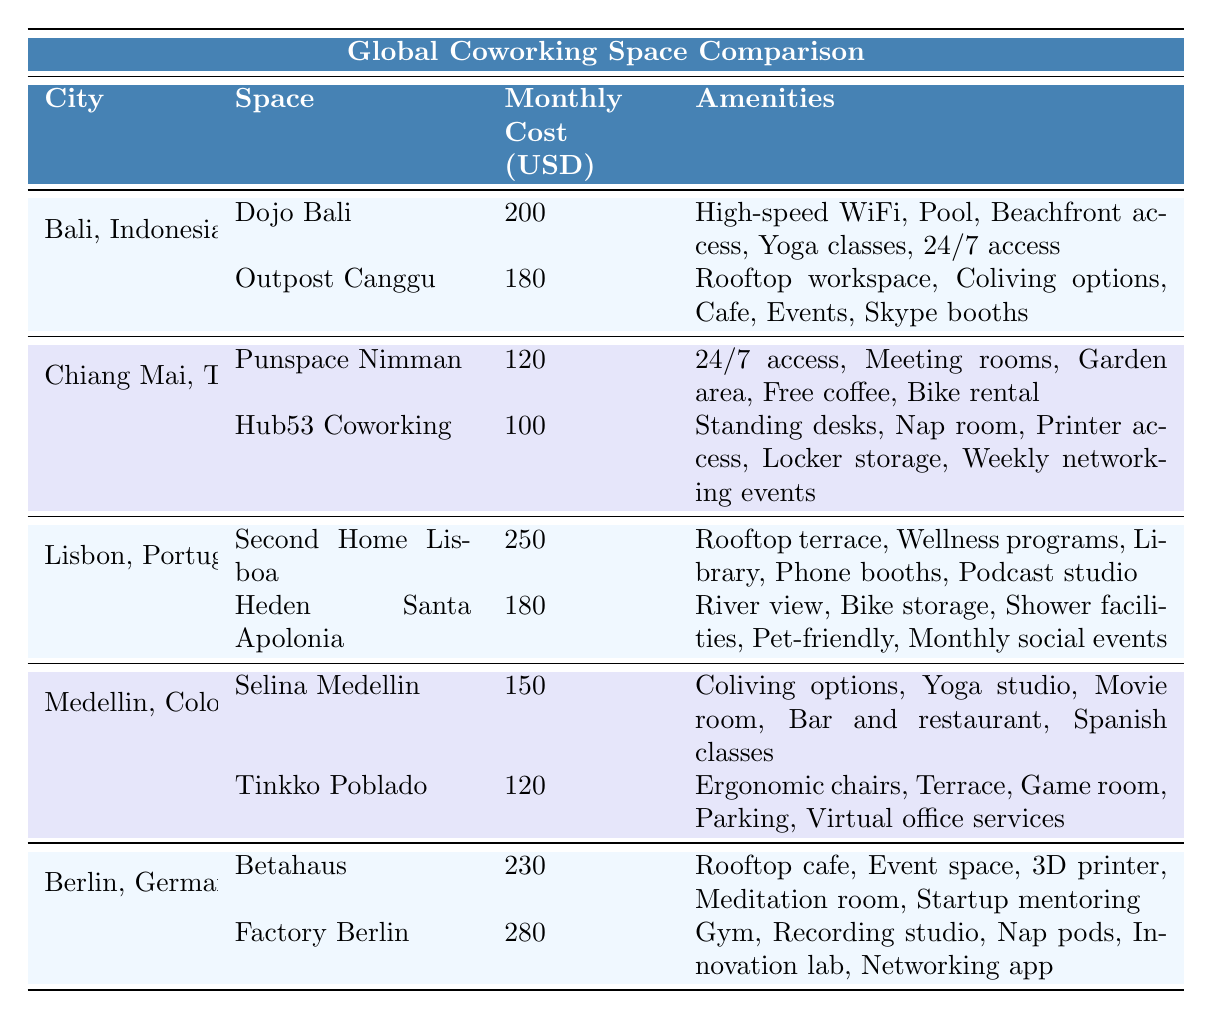What is the monthly cost of Dojo Bali? In the table, under the row for Bali, Indonesia, the monthly cost listed for Dojo Bali is directly provided as 200.
Answer: 200 How many amenities does Hub53 Coworking offer? For Hub53 Coworking in Chiang Mai, Thailand, there are five amenities listed: Standing desks, Nap room, Printer access, Locker storage, and Weekly networking events.
Answer: 5 Which coworking space has the highest monthly cost? By comparing the monthly costs in the table, Factory Berlin has the highest listed cost at 280.
Answer: 280 What amenities does Selina Medellin provide? The table lists five amenities for Selina Medellin: Coliving options, Yoga studio, Movie room, Bar and restaurant, and Spanish classes.
Answer: Coliving options, Yoga studio, Movie room, Bar and restaurant, Spanish classes What is the average monthly cost of coworking spaces in Berlin? There are two spaces in Berlin: Betahaus (230) and Factory Berlin (280). The total cost is 230 + 280 = 510, and there are 2 spaces, so the average is 510 / 2 = 255.
Answer: 255 Is Heden Santa Apolonia pet-friendly? The table specifies that Heden Santa Apolonia includes "Pet-friendly" among its amenities. Therefore, the statement is true.
Answer: Yes What is the total number of amenities offered by all coworking spaces in Chiang Mai? There are two spaces in Chiang Mai: Punspace Nimman (5 amenities) and Hub53 Coworking (5 amenities). Adding them gives 5 + 5 = 10 amenities total.
Answer: 10 Which city has the least expensive coworking space option? In the table, Hub53 Coworking in Chiang Mai has the lowest cost of 100, which is the least compared to others.
Answer: 100 How many coworking spaces in total are located in Bali and Berlin? Bali has two spaces (Dojo Bali and Outpost Canggu), and Berlin has two spaces (Betahaus and Factory Berlin), leading to a total of 2 + 2 = 4 spaces.
Answer: 4 What percentage of monthly costs exceed 200 USD? The spaces with costs greater than 200 are Second Home Lisboa (250), Betahaus (230), and Factory Berlin (280). Out of 10 spaces, 3 exceed 200, so (3/10) x 100 = 30%.
Answer: 30% 